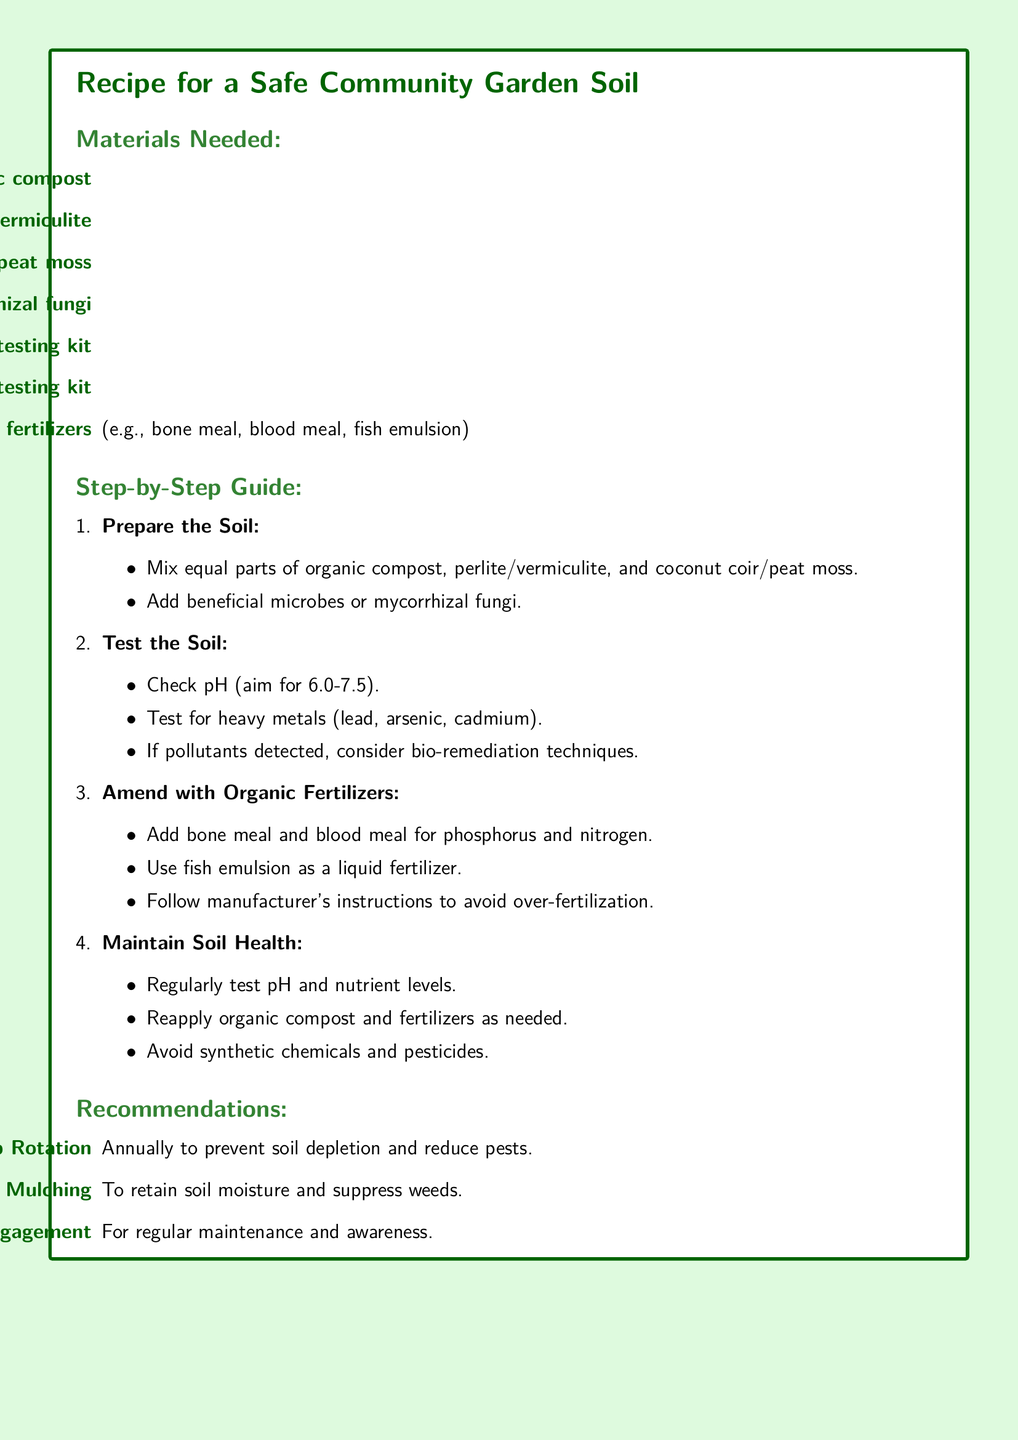what is the first step in the guide? The first step in the step-by-step guide is to prepare the soil, which involves mixing several materials together.
Answer: Prepare the Soil what organic material is recommended for soil amendment? The recipe suggests adding bone meal, blood meal, and fish emulsion as organic fertilizers for soil amendment.
Answer: Bone meal, blood meal, fish emulsion what is the target pH range for soil? The document specifies that the target pH range for soil is between 6.0 and 7.5.
Answer: 6.0-7.5 how many materials are listed under 'Materials Needed'? There are seven different materials listed under the 'Materials Needed' section.
Answer: Seven what technique is suggested if pollutants are detected in the soil? The document suggests considering bio-remediation techniques if pollutants are detected in the soil.
Answer: Bio-remediation techniques what is one recommended practice for maintaining soil health? One recommended practice for maintaining soil health is regularly testing pH and nutrient levels.
Answer: Regularly test pH and nutrient levels what is the purpose of crop rotation according to the recommendations? The purpose of crop rotation is to prevent soil depletion and reduce pests.
Answer: Prevent soil depletion and reduce pests what is the color of the box surrounding the recipe card? The box surrounding the recipe card has a dark green color for its frame.
Answer: Dark green 